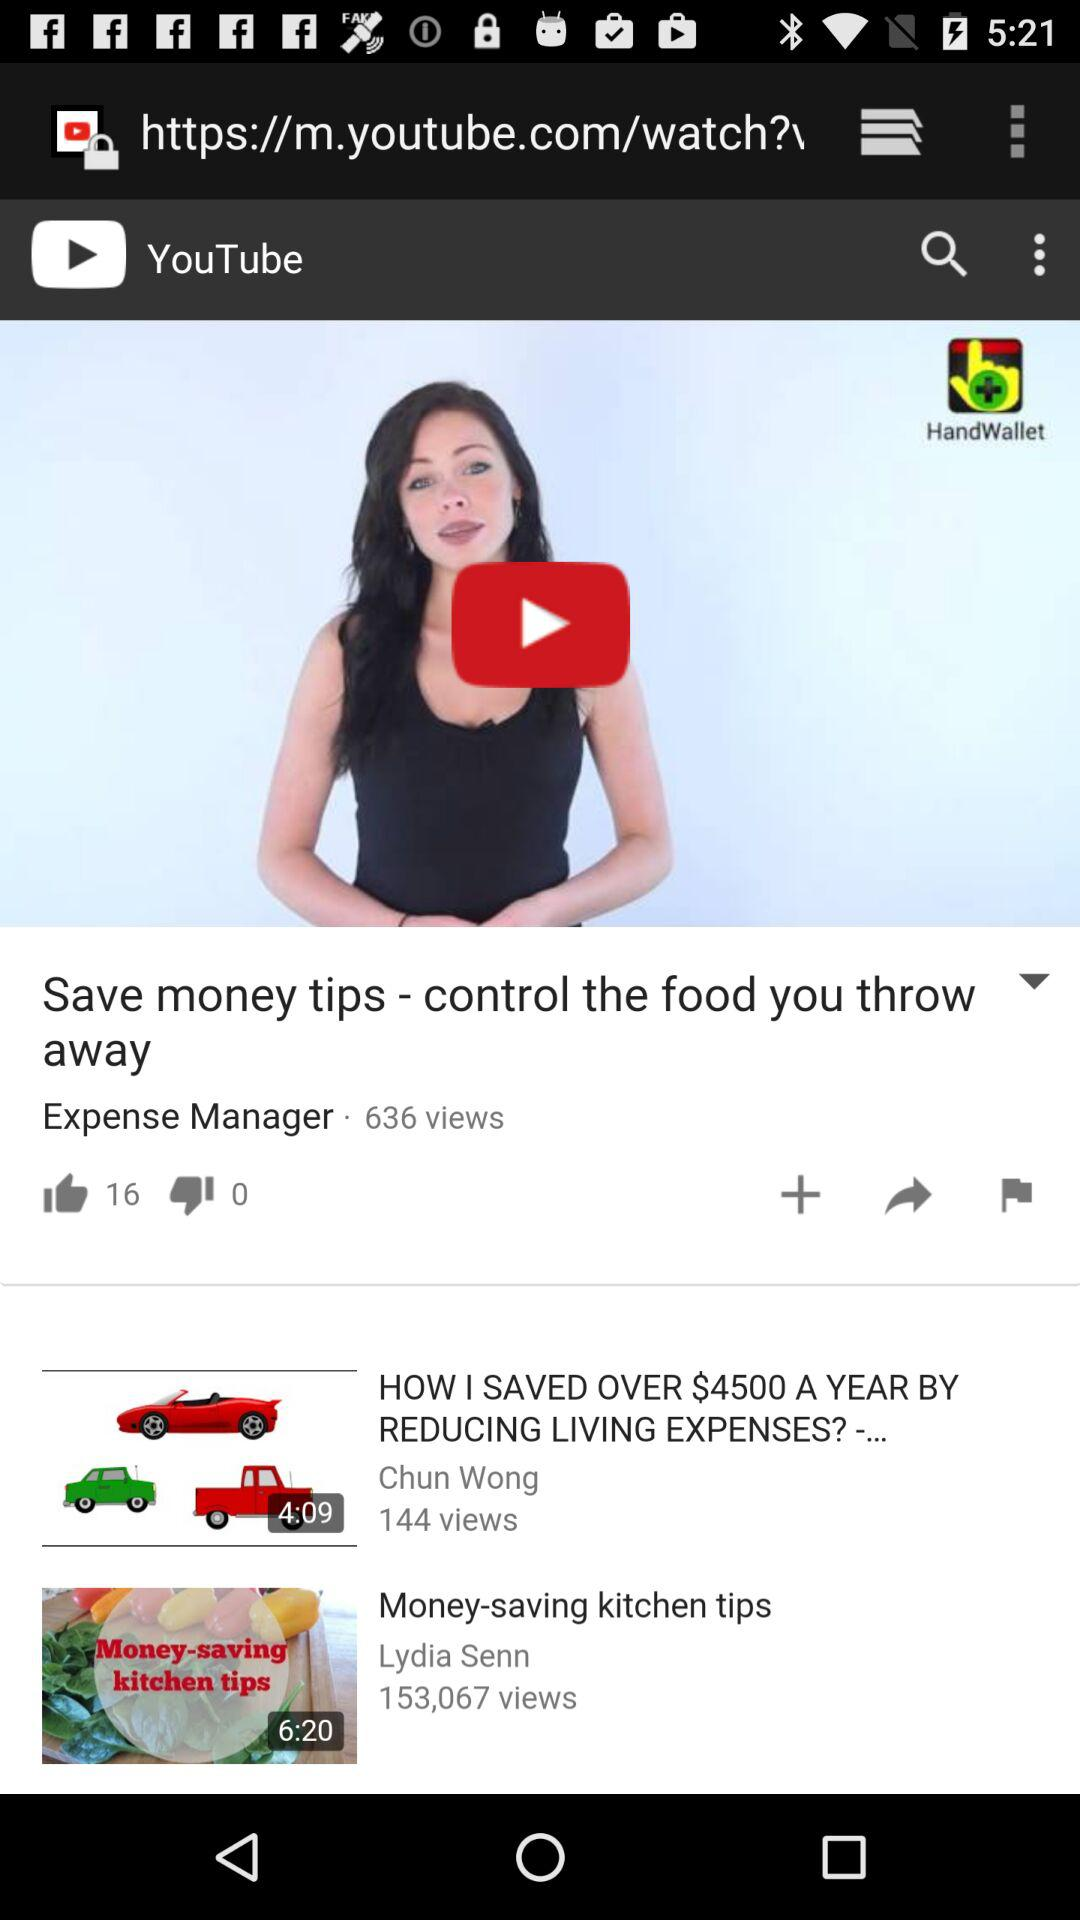What is the number of dislikes shown in this video? The number of dislikes is 0. 